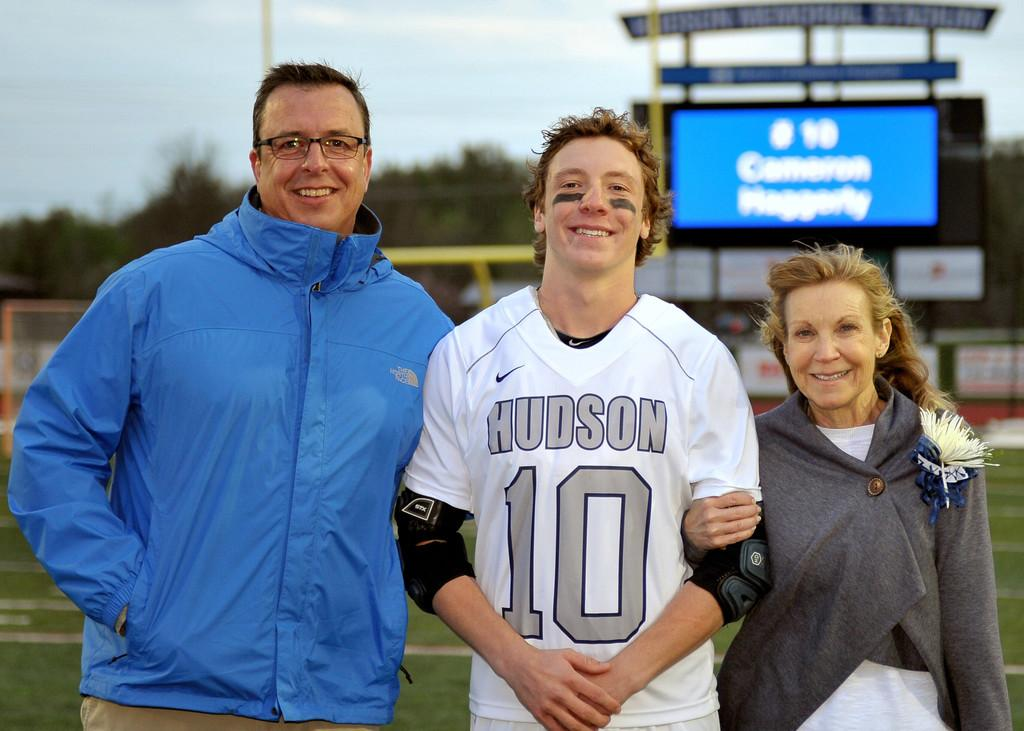<image>
Render a clear and concise summary of the photo. A man and a woman pose for a picture with a man wearing no. 10 jersey. 